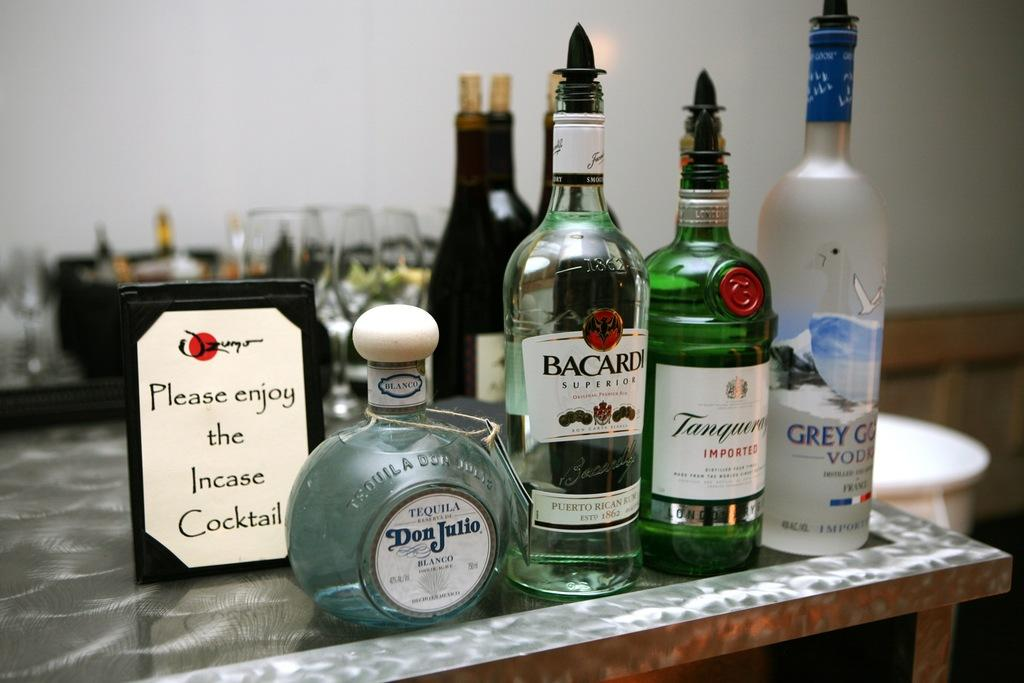<image>
Offer a succinct explanation of the picture presented. A bottle of Bacardi on a counter with other bottles of alcohol. 